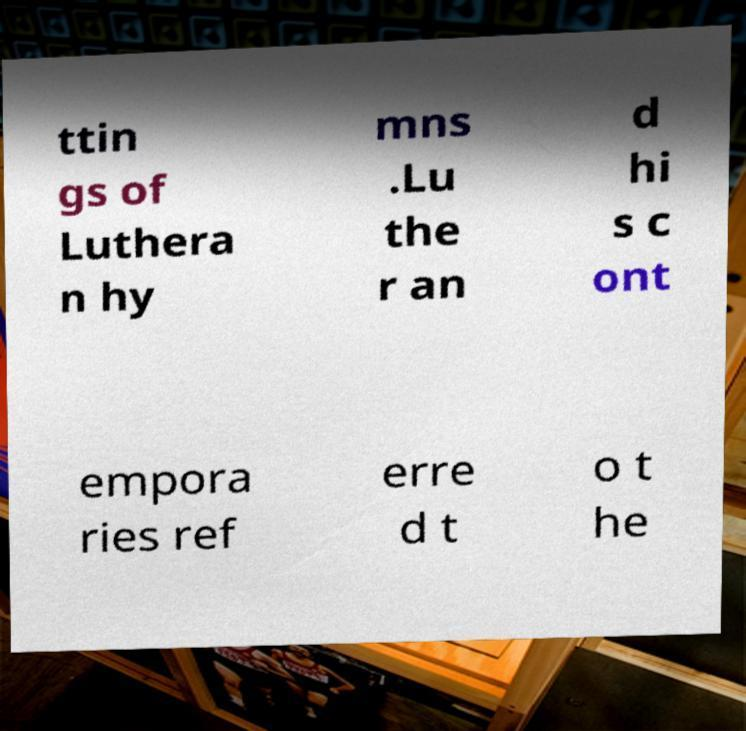There's text embedded in this image that I need extracted. Can you transcribe it verbatim? ttin gs of Luthera n hy mns .Lu the r an d hi s c ont empora ries ref erre d t o t he 